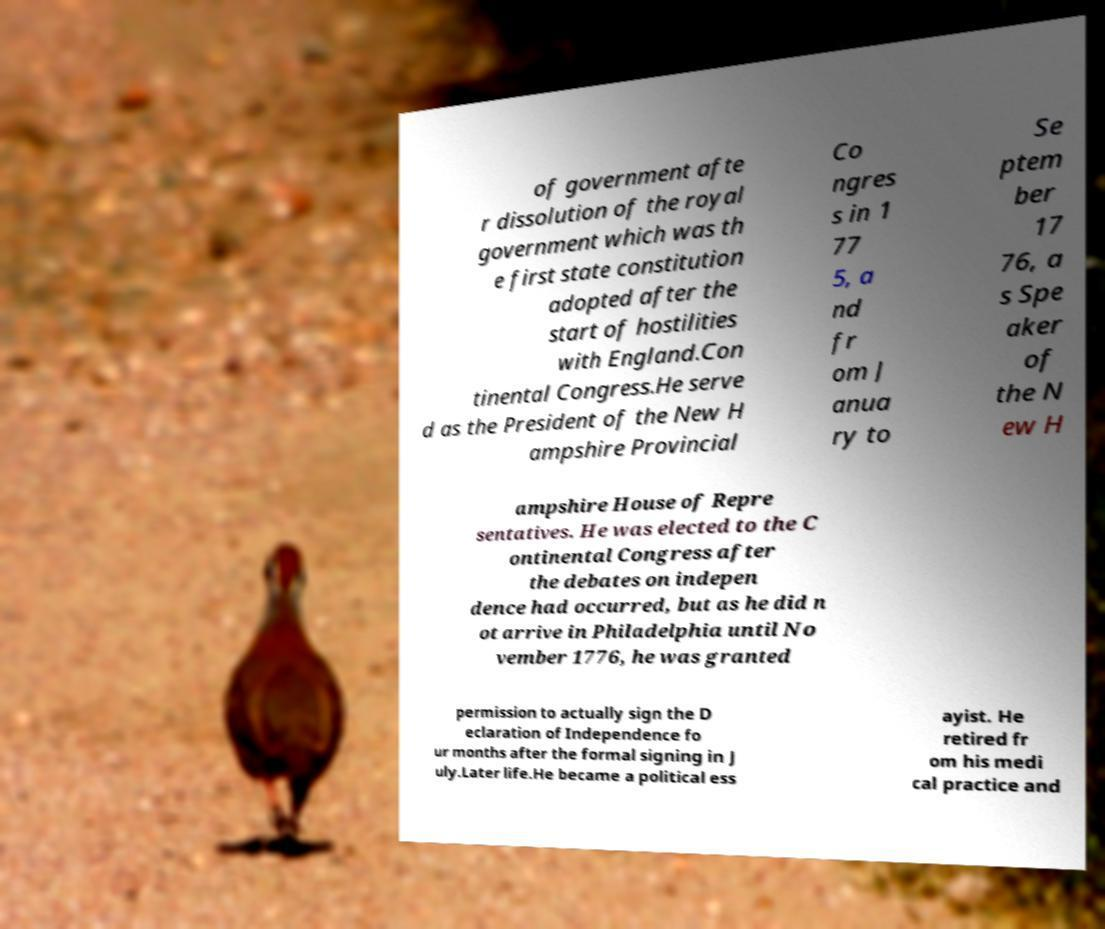Can you read and provide the text displayed in the image?This photo seems to have some interesting text. Can you extract and type it out for me? of government afte r dissolution of the royal government which was th e first state constitution adopted after the start of hostilities with England.Con tinental Congress.He serve d as the President of the New H ampshire Provincial Co ngres s in 1 77 5, a nd fr om J anua ry to Se ptem ber 17 76, a s Spe aker of the N ew H ampshire House of Repre sentatives. He was elected to the C ontinental Congress after the debates on indepen dence had occurred, but as he did n ot arrive in Philadelphia until No vember 1776, he was granted permission to actually sign the D eclaration of Independence fo ur months after the formal signing in J uly.Later life.He became a political ess ayist. He retired fr om his medi cal practice and 